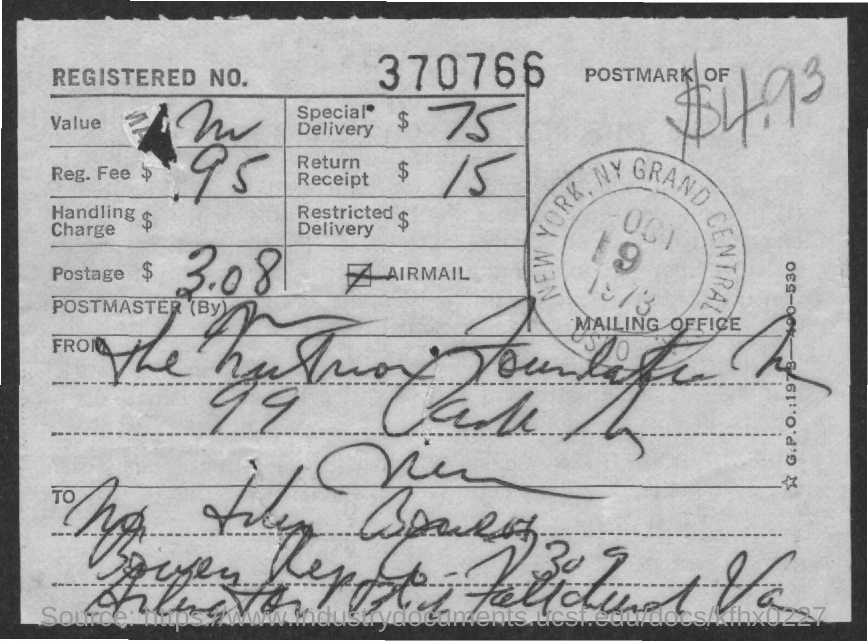Specify some key components in this picture. The registered number is 370766.. The registration fee is 95 cents. The fee for Special Delivery is $75. The fee for Return Receipt is $15. 